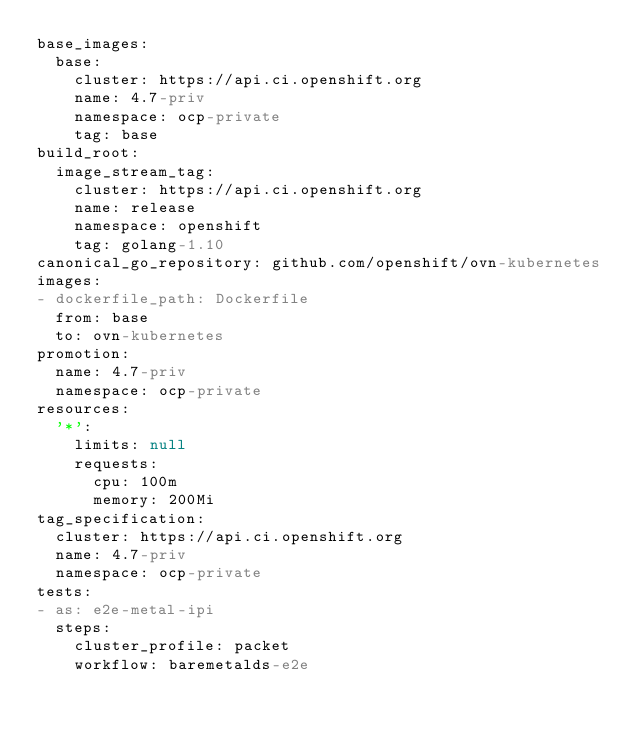Convert code to text. <code><loc_0><loc_0><loc_500><loc_500><_YAML_>base_images:
  base:
    cluster: https://api.ci.openshift.org
    name: 4.7-priv
    namespace: ocp-private
    tag: base
build_root:
  image_stream_tag:
    cluster: https://api.ci.openshift.org
    name: release
    namespace: openshift
    tag: golang-1.10
canonical_go_repository: github.com/openshift/ovn-kubernetes
images:
- dockerfile_path: Dockerfile
  from: base
  to: ovn-kubernetes
promotion:
  name: 4.7-priv
  namespace: ocp-private
resources:
  '*':
    limits: null
    requests:
      cpu: 100m
      memory: 200Mi
tag_specification:
  cluster: https://api.ci.openshift.org
  name: 4.7-priv
  namespace: ocp-private
tests:
- as: e2e-metal-ipi
  steps:
    cluster_profile: packet
    workflow: baremetalds-e2e
</code> 